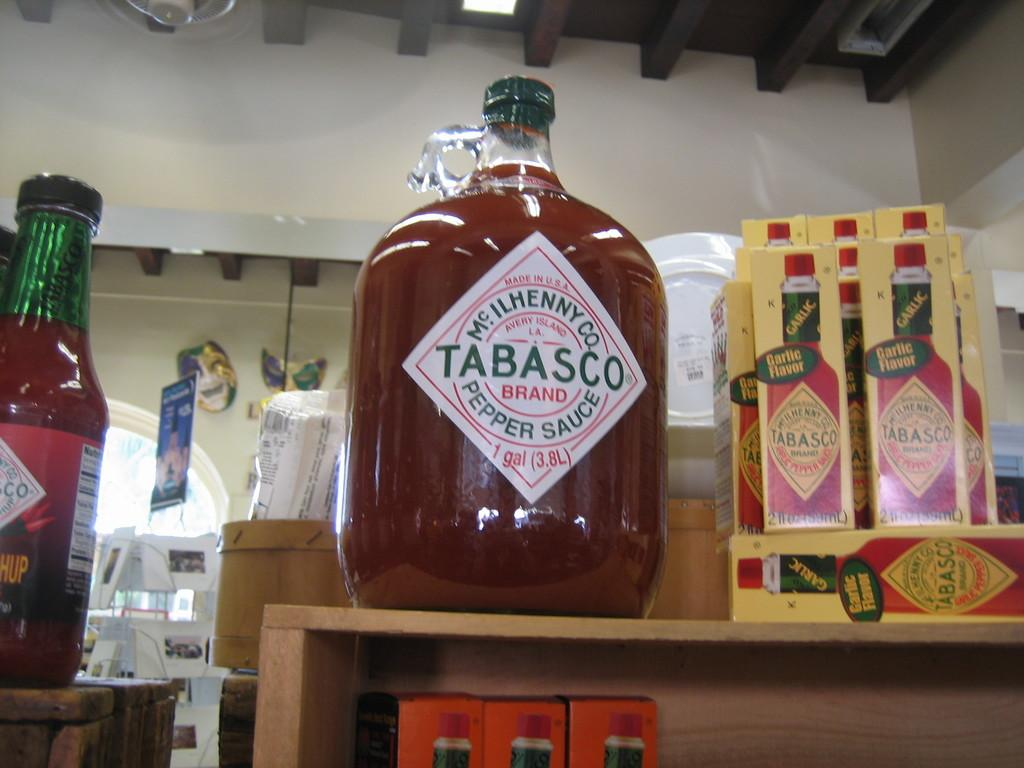<image>
Share a concise interpretation of the image provided. A really gigantic jug of Tabasco Sauce on a store display 